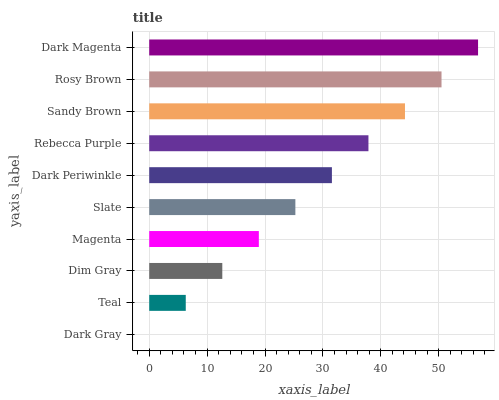Is Dark Gray the minimum?
Answer yes or no. Yes. Is Dark Magenta the maximum?
Answer yes or no. Yes. Is Teal the minimum?
Answer yes or no. No. Is Teal the maximum?
Answer yes or no. No. Is Teal greater than Dark Gray?
Answer yes or no. Yes. Is Dark Gray less than Teal?
Answer yes or no. Yes. Is Dark Gray greater than Teal?
Answer yes or no. No. Is Teal less than Dark Gray?
Answer yes or no. No. Is Dark Periwinkle the high median?
Answer yes or no. Yes. Is Slate the low median?
Answer yes or no. Yes. Is Rosy Brown the high median?
Answer yes or no. No. Is Rebecca Purple the low median?
Answer yes or no. No. 